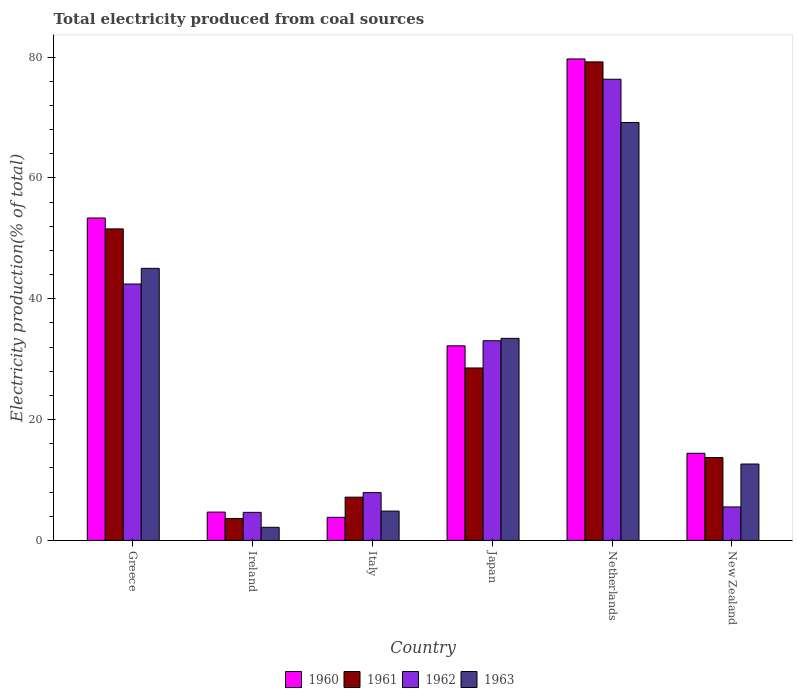How many different coloured bars are there?
Your answer should be very brief. 4. How many groups of bars are there?
Your response must be concise. 6. Are the number of bars on each tick of the X-axis equal?
Give a very brief answer. Yes. What is the label of the 1st group of bars from the left?
Your response must be concise. Greece. In how many cases, is the number of bars for a given country not equal to the number of legend labels?
Offer a terse response. 0. What is the total electricity produced in 1962 in Netherlands?
Offer a terse response. 76.33. Across all countries, what is the maximum total electricity produced in 1961?
Make the answer very short. 79.2. Across all countries, what is the minimum total electricity produced in 1962?
Provide a succinct answer. 4.64. In which country was the total electricity produced in 1962 minimum?
Provide a succinct answer. Ireland. What is the total total electricity produced in 1960 in the graph?
Ensure brevity in your answer.  188.18. What is the difference between the total electricity produced in 1963 in Ireland and that in Netherlands?
Make the answer very short. -67.01. What is the difference between the total electricity produced in 1962 in Greece and the total electricity produced in 1961 in Japan?
Ensure brevity in your answer.  13.9. What is the average total electricity produced in 1960 per country?
Your answer should be compact. 31.36. What is the difference between the total electricity produced of/in 1960 and total electricity produced of/in 1961 in Ireland?
Offer a terse response. 1.06. In how many countries, is the total electricity produced in 1962 greater than 20 %?
Give a very brief answer. 3. What is the ratio of the total electricity produced in 1960 in Netherlands to that in New Zealand?
Offer a terse response. 5.53. Is the total electricity produced in 1962 in Ireland less than that in New Zealand?
Ensure brevity in your answer.  Yes. What is the difference between the highest and the second highest total electricity produced in 1960?
Ensure brevity in your answer.  -21.15. What is the difference between the highest and the lowest total electricity produced in 1960?
Offer a very short reply. 75.87. Is the sum of the total electricity produced in 1961 in Greece and Ireland greater than the maximum total electricity produced in 1962 across all countries?
Keep it short and to the point. No. Is it the case that in every country, the sum of the total electricity produced in 1960 and total electricity produced in 1962 is greater than the total electricity produced in 1961?
Provide a succinct answer. Yes. How many bars are there?
Offer a terse response. 24. What is the difference between two consecutive major ticks on the Y-axis?
Offer a very short reply. 20. Are the values on the major ticks of Y-axis written in scientific E-notation?
Ensure brevity in your answer.  No. Does the graph contain any zero values?
Your answer should be compact. No. Does the graph contain grids?
Provide a succinct answer. No. Where does the legend appear in the graph?
Offer a terse response. Bottom center. What is the title of the graph?
Keep it short and to the point. Total electricity produced from coal sources. Does "1963" appear as one of the legend labels in the graph?
Make the answer very short. Yes. What is the label or title of the X-axis?
Provide a succinct answer. Country. What is the label or title of the Y-axis?
Your answer should be compact. Electricity production(% of total). What is the Electricity production(% of total) of 1960 in Greece?
Offer a very short reply. 53.36. What is the Electricity production(% of total) of 1961 in Greece?
Keep it short and to the point. 51.56. What is the Electricity production(% of total) in 1962 in Greece?
Give a very brief answer. 42.44. What is the Electricity production(% of total) of 1963 in Greece?
Your response must be concise. 45.03. What is the Electricity production(% of total) of 1960 in Ireland?
Make the answer very short. 4.69. What is the Electricity production(% of total) in 1961 in Ireland?
Offer a very short reply. 3.63. What is the Electricity production(% of total) of 1962 in Ireland?
Your answer should be very brief. 4.64. What is the Electricity production(% of total) in 1963 in Ireland?
Your answer should be compact. 2.16. What is the Electricity production(% of total) of 1960 in Italy?
Your answer should be very brief. 3.82. What is the Electricity production(% of total) in 1961 in Italy?
Provide a succinct answer. 7.15. What is the Electricity production(% of total) of 1962 in Italy?
Provide a short and direct response. 7.91. What is the Electricity production(% of total) of 1963 in Italy?
Your answer should be very brief. 4.85. What is the Electricity production(% of total) of 1960 in Japan?
Provide a succinct answer. 32.21. What is the Electricity production(% of total) in 1961 in Japan?
Keep it short and to the point. 28.54. What is the Electricity production(% of total) of 1962 in Japan?
Your answer should be very brief. 33.05. What is the Electricity production(% of total) of 1963 in Japan?
Ensure brevity in your answer.  33.44. What is the Electricity production(% of total) in 1960 in Netherlands?
Offer a very short reply. 79.69. What is the Electricity production(% of total) of 1961 in Netherlands?
Your response must be concise. 79.2. What is the Electricity production(% of total) in 1962 in Netherlands?
Make the answer very short. 76.33. What is the Electricity production(% of total) of 1963 in Netherlands?
Your response must be concise. 69.17. What is the Electricity production(% of total) of 1960 in New Zealand?
Offer a terse response. 14.42. What is the Electricity production(% of total) of 1961 in New Zealand?
Make the answer very short. 13.71. What is the Electricity production(% of total) in 1962 in New Zealand?
Provide a succinct answer. 5.54. What is the Electricity production(% of total) in 1963 in New Zealand?
Give a very brief answer. 12.64. Across all countries, what is the maximum Electricity production(% of total) of 1960?
Offer a terse response. 79.69. Across all countries, what is the maximum Electricity production(% of total) in 1961?
Make the answer very short. 79.2. Across all countries, what is the maximum Electricity production(% of total) of 1962?
Your answer should be compact. 76.33. Across all countries, what is the maximum Electricity production(% of total) of 1963?
Your answer should be very brief. 69.17. Across all countries, what is the minimum Electricity production(% of total) of 1960?
Offer a terse response. 3.82. Across all countries, what is the minimum Electricity production(% of total) of 1961?
Keep it short and to the point. 3.63. Across all countries, what is the minimum Electricity production(% of total) in 1962?
Offer a very short reply. 4.64. Across all countries, what is the minimum Electricity production(% of total) in 1963?
Offer a very short reply. 2.16. What is the total Electricity production(% of total) of 1960 in the graph?
Offer a terse response. 188.18. What is the total Electricity production(% of total) in 1961 in the graph?
Give a very brief answer. 183.8. What is the total Electricity production(% of total) in 1962 in the graph?
Ensure brevity in your answer.  169.91. What is the total Electricity production(% of total) of 1963 in the graph?
Provide a short and direct response. 167.3. What is the difference between the Electricity production(% of total) of 1960 in Greece and that in Ireland?
Make the answer very short. 48.68. What is the difference between the Electricity production(% of total) in 1961 in Greece and that in Ireland?
Offer a terse response. 47.93. What is the difference between the Electricity production(% of total) of 1962 in Greece and that in Ireland?
Provide a succinct answer. 37.8. What is the difference between the Electricity production(% of total) in 1963 in Greece and that in Ireland?
Give a very brief answer. 42.87. What is the difference between the Electricity production(% of total) of 1960 in Greece and that in Italy?
Make the answer very short. 49.54. What is the difference between the Electricity production(% of total) of 1961 in Greece and that in Italy?
Your answer should be compact. 44.41. What is the difference between the Electricity production(% of total) in 1962 in Greece and that in Italy?
Keep it short and to the point. 34.53. What is the difference between the Electricity production(% of total) in 1963 in Greece and that in Italy?
Give a very brief answer. 40.18. What is the difference between the Electricity production(% of total) in 1960 in Greece and that in Japan?
Keep it short and to the point. 21.15. What is the difference between the Electricity production(% of total) of 1961 in Greece and that in Japan?
Offer a terse response. 23.02. What is the difference between the Electricity production(% of total) of 1962 in Greece and that in Japan?
Give a very brief answer. 9.39. What is the difference between the Electricity production(% of total) in 1963 in Greece and that in Japan?
Make the answer very short. 11.59. What is the difference between the Electricity production(% of total) of 1960 in Greece and that in Netherlands?
Provide a succinct answer. -26.33. What is the difference between the Electricity production(% of total) in 1961 in Greece and that in Netherlands?
Your answer should be compact. -27.64. What is the difference between the Electricity production(% of total) of 1962 in Greece and that in Netherlands?
Your answer should be compact. -33.89. What is the difference between the Electricity production(% of total) of 1963 in Greece and that in Netherlands?
Your answer should be compact. -24.14. What is the difference between the Electricity production(% of total) of 1960 in Greece and that in New Zealand?
Ensure brevity in your answer.  38.95. What is the difference between the Electricity production(% of total) in 1961 in Greece and that in New Zealand?
Ensure brevity in your answer.  37.85. What is the difference between the Electricity production(% of total) of 1962 in Greece and that in New Zealand?
Offer a very short reply. 36.9. What is the difference between the Electricity production(% of total) of 1963 in Greece and that in New Zealand?
Provide a succinct answer. 32.39. What is the difference between the Electricity production(% of total) in 1960 in Ireland and that in Italy?
Keep it short and to the point. 0.87. What is the difference between the Electricity production(% of total) of 1961 in Ireland and that in Italy?
Offer a terse response. -3.53. What is the difference between the Electricity production(% of total) in 1962 in Ireland and that in Italy?
Your answer should be very brief. -3.27. What is the difference between the Electricity production(% of total) in 1963 in Ireland and that in Italy?
Offer a very short reply. -2.69. What is the difference between the Electricity production(% of total) in 1960 in Ireland and that in Japan?
Your response must be concise. -27.52. What is the difference between the Electricity production(% of total) of 1961 in Ireland and that in Japan?
Provide a succinct answer. -24.91. What is the difference between the Electricity production(% of total) of 1962 in Ireland and that in Japan?
Make the answer very short. -28.41. What is the difference between the Electricity production(% of total) of 1963 in Ireland and that in Japan?
Offer a terse response. -31.28. What is the difference between the Electricity production(% of total) in 1960 in Ireland and that in Netherlands?
Provide a succinct answer. -75.01. What is the difference between the Electricity production(% of total) of 1961 in Ireland and that in Netherlands?
Provide a short and direct response. -75.58. What is the difference between the Electricity production(% of total) in 1962 in Ireland and that in Netherlands?
Make the answer very short. -71.69. What is the difference between the Electricity production(% of total) in 1963 in Ireland and that in Netherlands?
Make the answer very short. -67.01. What is the difference between the Electricity production(% of total) of 1960 in Ireland and that in New Zealand?
Your response must be concise. -9.73. What is the difference between the Electricity production(% of total) in 1961 in Ireland and that in New Zealand?
Your answer should be compact. -10.08. What is the difference between the Electricity production(% of total) in 1962 in Ireland and that in New Zealand?
Keep it short and to the point. -0.9. What is the difference between the Electricity production(% of total) of 1963 in Ireland and that in New Zealand?
Your answer should be very brief. -10.48. What is the difference between the Electricity production(% of total) of 1960 in Italy and that in Japan?
Your answer should be compact. -28.39. What is the difference between the Electricity production(% of total) in 1961 in Italy and that in Japan?
Provide a short and direct response. -21.38. What is the difference between the Electricity production(% of total) of 1962 in Italy and that in Japan?
Provide a succinct answer. -25.14. What is the difference between the Electricity production(% of total) in 1963 in Italy and that in Japan?
Offer a terse response. -28.59. What is the difference between the Electricity production(% of total) in 1960 in Italy and that in Netherlands?
Offer a terse response. -75.87. What is the difference between the Electricity production(% of total) in 1961 in Italy and that in Netherlands?
Give a very brief answer. -72.05. What is the difference between the Electricity production(% of total) of 1962 in Italy and that in Netherlands?
Provide a succinct answer. -68.42. What is the difference between the Electricity production(% of total) of 1963 in Italy and that in Netherlands?
Keep it short and to the point. -64.32. What is the difference between the Electricity production(% of total) in 1960 in Italy and that in New Zealand?
Ensure brevity in your answer.  -10.6. What is the difference between the Electricity production(% of total) in 1961 in Italy and that in New Zealand?
Give a very brief answer. -6.55. What is the difference between the Electricity production(% of total) in 1962 in Italy and that in New Zealand?
Provide a short and direct response. 2.37. What is the difference between the Electricity production(% of total) of 1963 in Italy and that in New Zealand?
Offer a very short reply. -7.79. What is the difference between the Electricity production(% of total) of 1960 in Japan and that in Netherlands?
Provide a short and direct response. -47.48. What is the difference between the Electricity production(% of total) in 1961 in Japan and that in Netherlands?
Your response must be concise. -50.67. What is the difference between the Electricity production(% of total) in 1962 in Japan and that in Netherlands?
Provide a short and direct response. -43.28. What is the difference between the Electricity production(% of total) in 1963 in Japan and that in Netherlands?
Provide a short and direct response. -35.73. What is the difference between the Electricity production(% of total) in 1960 in Japan and that in New Zealand?
Offer a very short reply. 17.79. What is the difference between the Electricity production(% of total) of 1961 in Japan and that in New Zealand?
Provide a succinct answer. 14.83. What is the difference between the Electricity production(% of total) in 1962 in Japan and that in New Zealand?
Provide a short and direct response. 27.51. What is the difference between the Electricity production(% of total) of 1963 in Japan and that in New Zealand?
Make the answer very short. 20.8. What is the difference between the Electricity production(% of total) in 1960 in Netherlands and that in New Zealand?
Provide a succinct answer. 65.28. What is the difference between the Electricity production(% of total) in 1961 in Netherlands and that in New Zealand?
Offer a terse response. 65.5. What is the difference between the Electricity production(% of total) in 1962 in Netherlands and that in New Zealand?
Ensure brevity in your answer.  70.8. What is the difference between the Electricity production(% of total) of 1963 in Netherlands and that in New Zealand?
Offer a very short reply. 56.53. What is the difference between the Electricity production(% of total) of 1960 in Greece and the Electricity production(% of total) of 1961 in Ireland?
Offer a very short reply. 49.73. What is the difference between the Electricity production(% of total) of 1960 in Greece and the Electricity production(% of total) of 1962 in Ireland?
Ensure brevity in your answer.  48.72. What is the difference between the Electricity production(% of total) of 1960 in Greece and the Electricity production(% of total) of 1963 in Ireland?
Provide a succinct answer. 51.2. What is the difference between the Electricity production(% of total) in 1961 in Greece and the Electricity production(% of total) in 1962 in Ireland?
Your answer should be compact. 46.92. What is the difference between the Electricity production(% of total) of 1961 in Greece and the Electricity production(% of total) of 1963 in Ireland?
Ensure brevity in your answer.  49.4. What is the difference between the Electricity production(% of total) in 1962 in Greece and the Electricity production(% of total) in 1963 in Ireland?
Offer a terse response. 40.27. What is the difference between the Electricity production(% of total) in 1960 in Greece and the Electricity production(% of total) in 1961 in Italy?
Provide a succinct answer. 46.21. What is the difference between the Electricity production(% of total) in 1960 in Greece and the Electricity production(% of total) in 1962 in Italy?
Your answer should be very brief. 45.45. What is the difference between the Electricity production(% of total) of 1960 in Greece and the Electricity production(% of total) of 1963 in Italy?
Provide a short and direct response. 48.51. What is the difference between the Electricity production(% of total) of 1961 in Greece and the Electricity production(% of total) of 1962 in Italy?
Keep it short and to the point. 43.65. What is the difference between the Electricity production(% of total) in 1961 in Greece and the Electricity production(% of total) in 1963 in Italy?
Make the answer very short. 46.71. What is the difference between the Electricity production(% of total) of 1962 in Greece and the Electricity production(% of total) of 1963 in Italy?
Offer a very short reply. 37.59. What is the difference between the Electricity production(% of total) in 1960 in Greece and the Electricity production(% of total) in 1961 in Japan?
Provide a succinct answer. 24.82. What is the difference between the Electricity production(% of total) of 1960 in Greece and the Electricity production(% of total) of 1962 in Japan?
Give a very brief answer. 20.31. What is the difference between the Electricity production(% of total) in 1960 in Greece and the Electricity production(% of total) in 1963 in Japan?
Your answer should be very brief. 19.92. What is the difference between the Electricity production(% of total) in 1961 in Greece and the Electricity production(% of total) in 1962 in Japan?
Your answer should be compact. 18.51. What is the difference between the Electricity production(% of total) of 1961 in Greece and the Electricity production(% of total) of 1963 in Japan?
Give a very brief answer. 18.12. What is the difference between the Electricity production(% of total) of 1962 in Greece and the Electricity production(% of total) of 1963 in Japan?
Offer a very short reply. 9. What is the difference between the Electricity production(% of total) of 1960 in Greece and the Electricity production(% of total) of 1961 in Netherlands?
Offer a very short reply. -25.84. What is the difference between the Electricity production(% of total) in 1960 in Greece and the Electricity production(% of total) in 1962 in Netherlands?
Keep it short and to the point. -22.97. What is the difference between the Electricity production(% of total) in 1960 in Greece and the Electricity production(% of total) in 1963 in Netherlands?
Ensure brevity in your answer.  -15.81. What is the difference between the Electricity production(% of total) of 1961 in Greece and the Electricity production(% of total) of 1962 in Netherlands?
Offer a very short reply. -24.77. What is the difference between the Electricity production(% of total) of 1961 in Greece and the Electricity production(% of total) of 1963 in Netherlands?
Make the answer very short. -17.61. What is the difference between the Electricity production(% of total) of 1962 in Greece and the Electricity production(% of total) of 1963 in Netherlands?
Offer a terse response. -26.73. What is the difference between the Electricity production(% of total) of 1960 in Greece and the Electricity production(% of total) of 1961 in New Zealand?
Your answer should be very brief. 39.65. What is the difference between the Electricity production(% of total) in 1960 in Greece and the Electricity production(% of total) in 1962 in New Zealand?
Keep it short and to the point. 47.83. What is the difference between the Electricity production(% of total) of 1960 in Greece and the Electricity production(% of total) of 1963 in New Zealand?
Provide a short and direct response. 40.72. What is the difference between the Electricity production(% of total) in 1961 in Greece and the Electricity production(% of total) in 1962 in New Zealand?
Keep it short and to the point. 46.03. What is the difference between the Electricity production(% of total) in 1961 in Greece and the Electricity production(% of total) in 1963 in New Zealand?
Ensure brevity in your answer.  38.92. What is the difference between the Electricity production(% of total) of 1962 in Greece and the Electricity production(% of total) of 1963 in New Zealand?
Your response must be concise. 29.8. What is the difference between the Electricity production(% of total) of 1960 in Ireland and the Electricity production(% of total) of 1961 in Italy?
Provide a succinct answer. -2.47. What is the difference between the Electricity production(% of total) in 1960 in Ireland and the Electricity production(% of total) in 1962 in Italy?
Ensure brevity in your answer.  -3.22. What is the difference between the Electricity production(% of total) in 1960 in Ireland and the Electricity production(% of total) in 1963 in Italy?
Make the answer very short. -0.17. What is the difference between the Electricity production(% of total) in 1961 in Ireland and the Electricity production(% of total) in 1962 in Italy?
Provide a short and direct response. -4.28. What is the difference between the Electricity production(% of total) in 1961 in Ireland and the Electricity production(% of total) in 1963 in Italy?
Give a very brief answer. -1.22. What is the difference between the Electricity production(% of total) of 1962 in Ireland and the Electricity production(% of total) of 1963 in Italy?
Offer a terse response. -0.21. What is the difference between the Electricity production(% of total) of 1960 in Ireland and the Electricity production(% of total) of 1961 in Japan?
Provide a short and direct response. -23.85. What is the difference between the Electricity production(% of total) in 1960 in Ireland and the Electricity production(% of total) in 1962 in Japan?
Provide a succinct answer. -28.36. What is the difference between the Electricity production(% of total) in 1960 in Ireland and the Electricity production(% of total) in 1963 in Japan?
Offer a very short reply. -28.76. What is the difference between the Electricity production(% of total) of 1961 in Ireland and the Electricity production(% of total) of 1962 in Japan?
Your answer should be compact. -29.42. What is the difference between the Electricity production(% of total) of 1961 in Ireland and the Electricity production(% of total) of 1963 in Japan?
Provide a succinct answer. -29.82. What is the difference between the Electricity production(% of total) of 1962 in Ireland and the Electricity production(% of total) of 1963 in Japan?
Offer a very short reply. -28.8. What is the difference between the Electricity production(% of total) of 1960 in Ireland and the Electricity production(% of total) of 1961 in Netherlands?
Offer a terse response. -74.52. What is the difference between the Electricity production(% of total) of 1960 in Ireland and the Electricity production(% of total) of 1962 in Netherlands?
Offer a very short reply. -71.65. What is the difference between the Electricity production(% of total) of 1960 in Ireland and the Electricity production(% of total) of 1963 in Netherlands?
Offer a very short reply. -64.49. What is the difference between the Electricity production(% of total) in 1961 in Ireland and the Electricity production(% of total) in 1962 in Netherlands?
Make the answer very short. -72.71. What is the difference between the Electricity production(% of total) in 1961 in Ireland and the Electricity production(% of total) in 1963 in Netherlands?
Make the answer very short. -65.54. What is the difference between the Electricity production(% of total) of 1962 in Ireland and the Electricity production(% of total) of 1963 in Netherlands?
Your answer should be very brief. -64.53. What is the difference between the Electricity production(% of total) in 1960 in Ireland and the Electricity production(% of total) in 1961 in New Zealand?
Give a very brief answer. -9.02. What is the difference between the Electricity production(% of total) in 1960 in Ireland and the Electricity production(% of total) in 1962 in New Zealand?
Keep it short and to the point. -0.85. What is the difference between the Electricity production(% of total) of 1960 in Ireland and the Electricity production(% of total) of 1963 in New Zealand?
Offer a terse response. -7.95. What is the difference between the Electricity production(% of total) of 1961 in Ireland and the Electricity production(% of total) of 1962 in New Zealand?
Give a very brief answer. -1.91. What is the difference between the Electricity production(% of total) of 1961 in Ireland and the Electricity production(% of total) of 1963 in New Zealand?
Your answer should be very brief. -9.01. What is the difference between the Electricity production(% of total) in 1962 in Ireland and the Electricity production(% of total) in 1963 in New Zealand?
Ensure brevity in your answer.  -8. What is the difference between the Electricity production(% of total) in 1960 in Italy and the Electricity production(% of total) in 1961 in Japan?
Provide a short and direct response. -24.72. What is the difference between the Electricity production(% of total) in 1960 in Italy and the Electricity production(% of total) in 1962 in Japan?
Give a very brief answer. -29.23. What is the difference between the Electricity production(% of total) of 1960 in Italy and the Electricity production(% of total) of 1963 in Japan?
Offer a very short reply. -29.63. What is the difference between the Electricity production(% of total) of 1961 in Italy and the Electricity production(% of total) of 1962 in Japan?
Keep it short and to the point. -25.89. What is the difference between the Electricity production(% of total) of 1961 in Italy and the Electricity production(% of total) of 1963 in Japan?
Make the answer very short. -26.29. What is the difference between the Electricity production(% of total) of 1962 in Italy and the Electricity production(% of total) of 1963 in Japan?
Your answer should be compact. -25.53. What is the difference between the Electricity production(% of total) of 1960 in Italy and the Electricity production(% of total) of 1961 in Netherlands?
Provide a short and direct response. -75.39. What is the difference between the Electricity production(% of total) of 1960 in Italy and the Electricity production(% of total) of 1962 in Netherlands?
Your answer should be very brief. -72.51. What is the difference between the Electricity production(% of total) of 1960 in Italy and the Electricity production(% of total) of 1963 in Netherlands?
Ensure brevity in your answer.  -65.35. What is the difference between the Electricity production(% of total) of 1961 in Italy and the Electricity production(% of total) of 1962 in Netherlands?
Provide a succinct answer. -69.18. What is the difference between the Electricity production(% of total) in 1961 in Italy and the Electricity production(% of total) in 1963 in Netherlands?
Offer a very short reply. -62.02. What is the difference between the Electricity production(% of total) of 1962 in Italy and the Electricity production(% of total) of 1963 in Netherlands?
Your response must be concise. -61.26. What is the difference between the Electricity production(% of total) of 1960 in Italy and the Electricity production(% of total) of 1961 in New Zealand?
Provide a short and direct response. -9.89. What is the difference between the Electricity production(% of total) in 1960 in Italy and the Electricity production(% of total) in 1962 in New Zealand?
Your response must be concise. -1.72. What is the difference between the Electricity production(% of total) in 1960 in Italy and the Electricity production(% of total) in 1963 in New Zealand?
Your answer should be compact. -8.82. What is the difference between the Electricity production(% of total) in 1961 in Italy and the Electricity production(% of total) in 1962 in New Zealand?
Your response must be concise. 1.62. What is the difference between the Electricity production(% of total) in 1961 in Italy and the Electricity production(% of total) in 1963 in New Zealand?
Provide a succinct answer. -5.49. What is the difference between the Electricity production(% of total) of 1962 in Italy and the Electricity production(% of total) of 1963 in New Zealand?
Offer a terse response. -4.73. What is the difference between the Electricity production(% of total) in 1960 in Japan and the Electricity production(% of total) in 1961 in Netherlands?
Offer a very short reply. -47. What is the difference between the Electricity production(% of total) in 1960 in Japan and the Electricity production(% of total) in 1962 in Netherlands?
Offer a very short reply. -44.13. What is the difference between the Electricity production(% of total) in 1960 in Japan and the Electricity production(% of total) in 1963 in Netherlands?
Offer a terse response. -36.96. What is the difference between the Electricity production(% of total) in 1961 in Japan and the Electricity production(% of total) in 1962 in Netherlands?
Provide a short and direct response. -47.79. What is the difference between the Electricity production(% of total) in 1961 in Japan and the Electricity production(% of total) in 1963 in Netherlands?
Keep it short and to the point. -40.63. What is the difference between the Electricity production(% of total) of 1962 in Japan and the Electricity production(% of total) of 1963 in Netherlands?
Provide a short and direct response. -36.12. What is the difference between the Electricity production(% of total) in 1960 in Japan and the Electricity production(% of total) in 1961 in New Zealand?
Your answer should be compact. 18.5. What is the difference between the Electricity production(% of total) of 1960 in Japan and the Electricity production(% of total) of 1962 in New Zealand?
Provide a succinct answer. 26.67. What is the difference between the Electricity production(% of total) in 1960 in Japan and the Electricity production(% of total) in 1963 in New Zealand?
Offer a very short reply. 19.57. What is the difference between the Electricity production(% of total) in 1961 in Japan and the Electricity production(% of total) in 1962 in New Zealand?
Give a very brief answer. 23. What is the difference between the Electricity production(% of total) in 1961 in Japan and the Electricity production(% of total) in 1963 in New Zealand?
Your answer should be compact. 15.9. What is the difference between the Electricity production(% of total) of 1962 in Japan and the Electricity production(% of total) of 1963 in New Zealand?
Provide a short and direct response. 20.41. What is the difference between the Electricity production(% of total) of 1960 in Netherlands and the Electricity production(% of total) of 1961 in New Zealand?
Ensure brevity in your answer.  65.98. What is the difference between the Electricity production(% of total) in 1960 in Netherlands and the Electricity production(% of total) in 1962 in New Zealand?
Make the answer very short. 74.16. What is the difference between the Electricity production(% of total) of 1960 in Netherlands and the Electricity production(% of total) of 1963 in New Zealand?
Ensure brevity in your answer.  67.05. What is the difference between the Electricity production(% of total) of 1961 in Netherlands and the Electricity production(% of total) of 1962 in New Zealand?
Offer a very short reply. 73.67. What is the difference between the Electricity production(% of total) of 1961 in Netherlands and the Electricity production(% of total) of 1963 in New Zealand?
Give a very brief answer. 66.56. What is the difference between the Electricity production(% of total) in 1962 in Netherlands and the Electricity production(% of total) in 1963 in New Zealand?
Provide a short and direct response. 63.69. What is the average Electricity production(% of total) in 1960 per country?
Keep it short and to the point. 31.36. What is the average Electricity production(% of total) of 1961 per country?
Ensure brevity in your answer.  30.63. What is the average Electricity production(% of total) in 1962 per country?
Offer a terse response. 28.32. What is the average Electricity production(% of total) of 1963 per country?
Your answer should be compact. 27.88. What is the difference between the Electricity production(% of total) of 1960 and Electricity production(% of total) of 1961 in Greece?
Provide a succinct answer. 1.8. What is the difference between the Electricity production(% of total) of 1960 and Electricity production(% of total) of 1962 in Greece?
Give a very brief answer. 10.92. What is the difference between the Electricity production(% of total) in 1960 and Electricity production(% of total) in 1963 in Greece?
Keep it short and to the point. 8.33. What is the difference between the Electricity production(% of total) in 1961 and Electricity production(% of total) in 1962 in Greece?
Offer a very short reply. 9.12. What is the difference between the Electricity production(% of total) in 1961 and Electricity production(% of total) in 1963 in Greece?
Offer a terse response. 6.53. What is the difference between the Electricity production(% of total) in 1962 and Electricity production(% of total) in 1963 in Greece?
Offer a very short reply. -2.59. What is the difference between the Electricity production(% of total) of 1960 and Electricity production(% of total) of 1961 in Ireland?
Your response must be concise. 1.06. What is the difference between the Electricity production(% of total) of 1960 and Electricity production(% of total) of 1962 in Ireland?
Ensure brevity in your answer.  0.05. What is the difference between the Electricity production(% of total) of 1960 and Electricity production(% of total) of 1963 in Ireland?
Ensure brevity in your answer.  2.52. What is the difference between the Electricity production(% of total) in 1961 and Electricity production(% of total) in 1962 in Ireland?
Your answer should be very brief. -1.01. What is the difference between the Electricity production(% of total) in 1961 and Electricity production(% of total) in 1963 in Ireland?
Your answer should be compact. 1.46. What is the difference between the Electricity production(% of total) in 1962 and Electricity production(% of total) in 1963 in Ireland?
Give a very brief answer. 2.48. What is the difference between the Electricity production(% of total) of 1960 and Electricity production(% of total) of 1961 in Italy?
Your response must be concise. -3.34. What is the difference between the Electricity production(% of total) in 1960 and Electricity production(% of total) in 1962 in Italy?
Your answer should be very brief. -4.09. What is the difference between the Electricity production(% of total) in 1960 and Electricity production(% of total) in 1963 in Italy?
Your answer should be very brief. -1.03. What is the difference between the Electricity production(% of total) of 1961 and Electricity production(% of total) of 1962 in Italy?
Provide a succinct answer. -0.75. What is the difference between the Electricity production(% of total) of 1961 and Electricity production(% of total) of 1963 in Italy?
Ensure brevity in your answer.  2.3. What is the difference between the Electricity production(% of total) in 1962 and Electricity production(% of total) in 1963 in Italy?
Make the answer very short. 3.06. What is the difference between the Electricity production(% of total) of 1960 and Electricity production(% of total) of 1961 in Japan?
Make the answer very short. 3.67. What is the difference between the Electricity production(% of total) of 1960 and Electricity production(% of total) of 1962 in Japan?
Give a very brief answer. -0.84. What is the difference between the Electricity production(% of total) of 1960 and Electricity production(% of total) of 1963 in Japan?
Offer a very short reply. -1.24. What is the difference between the Electricity production(% of total) of 1961 and Electricity production(% of total) of 1962 in Japan?
Your response must be concise. -4.51. What is the difference between the Electricity production(% of total) in 1961 and Electricity production(% of total) in 1963 in Japan?
Offer a terse response. -4.9. What is the difference between the Electricity production(% of total) in 1962 and Electricity production(% of total) in 1963 in Japan?
Your answer should be very brief. -0.4. What is the difference between the Electricity production(% of total) in 1960 and Electricity production(% of total) in 1961 in Netherlands?
Provide a succinct answer. 0.49. What is the difference between the Electricity production(% of total) in 1960 and Electricity production(% of total) in 1962 in Netherlands?
Provide a short and direct response. 3.36. What is the difference between the Electricity production(% of total) in 1960 and Electricity production(% of total) in 1963 in Netherlands?
Your answer should be compact. 10.52. What is the difference between the Electricity production(% of total) of 1961 and Electricity production(% of total) of 1962 in Netherlands?
Offer a very short reply. 2.87. What is the difference between the Electricity production(% of total) in 1961 and Electricity production(% of total) in 1963 in Netherlands?
Keep it short and to the point. 10.03. What is the difference between the Electricity production(% of total) of 1962 and Electricity production(% of total) of 1963 in Netherlands?
Make the answer very short. 7.16. What is the difference between the Electricity production(% of total) in 1960 and Electricity production(% of total) in 1961 in New Zealand?
Give a very brief answer. 0.71. What is the difference between the Electricity production(% of total) of 1960 and Electricity production(% of total) of 1962 in New Zealand?
Provide a short and direct response. 8.88. What is the difference between the Electricity production(% of total) in 1960 and Electricity production(% of total) in 1963 in New Zealand?
Offer a very short reply. 1.78. What is the difference between the Electricity production(% of total) of 1961 and Electricity production(% of total) of 1962 in New Zealand?
Your answer should be compact. 8.17. What is the difference between the Electricity production(% of total) of 1961 and Electricity production(% of total) of 1963 in New Zealand?
Offer a terse response. 1.07. What is the difference between the Electricity production(% of total) in 1962 and Electricity production(% of total) in 1963 in New Zealand?
Provide a short and direct response. -7.1. What is the ratio of the Electricity production(% of total) in 1960 in Greece to that in Ireland?
Provide a succinct answer. 11.39. What is the ratio of the Electricity production(% of total) of 1961 in Greece to that in Ireland?
Your answer should be very brief. 14.21. What is the ratio of the Electricity production(% of total) in 1962 in Greece to that in Ireland?
Your response must be concise. 9.14. What is the ratio of the Electricity production(% of total) of 1963 in Greece to that in Ireland?
Provide a succinct answer. 20.8. What is the ratio of the Electricity production(% of total) of 1960 in Greece to that in Italy?
Your response must be concise. 13.97. What is the ratio of the Electricity production(% of total) in 1961 in Greece to that in Italy?
Your response must be concise. 7.21. What is the ratio of the Electricity production(% of total) of 1962 in Greece to that in Italy?
Offer a terse response. 5.37. What is the ratio of the Electricity production(% of total) of 1963 in Greece to that in Italy?
Ensure brevity in your answer.  9.28. What is the ratio of the Electricity production(% of total) of 1960 in Greece to that in Japan?
Your response must be concise. 1.66. What is the ratio of the Electricity production(% of total) of 1961 in Greece to that in Japan?
Offer a terse response. 1.81. What is the ratio of the Electricity production(% of total) of 1962 in Greece to that in Japan?
Provide a succinct answer. 1.28. What is the ratio of the Electricity production(% of total) of 1963 in Greece to that in Japan?
Your answer should be very brief. 1.35. What is the ratio of the Electricity production(% of total) in 1960 in Greece to that in Netherlands?
Provide a short and direct response. 0.67. What is the ratio of the Electricity production(% of total) of 1961 in Greece to that in Netherlands?
Your response must be concise. 0.65. What is the ratio of the Electricity production(% of total) in 1962 in Greece to that in Netherlands?
Provide a short and direct response. 0.56. What is the ratio of the Electricity production(% of total) in 1963 in Greece to that in Netherlands?
Your response must be concise. 0.65. What is the ratio of the Electricity production(% of total) of 1960 in Greece to that in New Zealand?
Provide a succinct answer. 3.7. What is the ratio of the Electricity production(% of total) of 1961 in Greece to that in New Zealand?
Make the answer very short. 3.76. What is the ratio of the Electricity production(% of total) of 1962 in Greece to that in New Zealand?
Ensure brevity in your answer.  7.67. What is the ratio of the Electricity production(% of total) in 1963 in Greece to that in New Zealand?
Your response must be concise. 3.56. What is the ratio of the Electricity production(% of total) in 1960 in Ireland to that in Italy?
Provide a succinct answer. 1.23. What is the ratio of the Electricity production(% of total) of 1961 in Ireland to that in Italy?
Your answer should be compact. 0.51. What is the ratio of the Electricity production(% of total) of 1962 in Ireland to that in Italy?
Offer a very short reply. 0.59. What is the ratio of the Electricity production(% of total) of 1963 in Ireland to that in Italy?
Offer a very short reply. 0.45. What is the ratio of the Electricity production(% of total) in 1960 in Ireland to that in Japan?
Provide a short and direct response. 0.15. What is the ratio of the Electricity production(% of total) of 1961 in Ireland to that in Japan?
Offer a very short reply. 0.13. What is the ratio of the Electricity production(% of total) of 1962 in Ireland to that in Japan?
Provide a succinct answer. 0.14. What is the ratio of the Electricity production(% of total) of 1963 in Ireland to that in Japan?
Your response must be concise. 0.06. What is the ratio of the Electricity production(% of total) of 1960 in Ireland to that in Netherlands?
Offer a very short reply. 0.06. What is the ratio of the Electricity production(% of total) of 1961 in Ireland to that in Netherlands?
Your response must be concise. 0.05. What is the ratio of the Electricity production(% of total) of 1962 in Ireland to that in Netherlands?
Make the answer very short. 0.06. What is the ratio of the Electricity production(% of total) in 1963 in Ireland to that in Netherlands?
Your response must be concise. 0.03. What is the ratio of the Electricity production(% of total) of 1960 in Ireland to that in New Zealand?
Your answer should be very brief. 0.33. What is the ratio of the Electricity production(% of total) in 1961 in Ireland to that in New Zealand?
Ensure brevity in your answer.  0.26. What is the ratio of the Electricity production(% of total) in 1962 in Ireland to that in New Zealand?
Your answer should be very brief. 0.84. What is the ratio of the Electricity production(% of total) in 1963 in Ireland to that in New Zealand?
Offer a very short reply. 0.17. What is the ratio of the Electricity production(% of total) in 1960 in Italy to that in Japan?
Offer a terse response. 0.12. What is the ratio of the Electricity production(% of total) in 1961 in Italy to that in Japan?
Give a very brief answer. 0.25. What is the ratio of the Electricity production(% of total) in 1962 in Italy to that in Japan?
Provide a short and direct response. 0.24. What is the ratio of the Electricity production(% of total) in 1963 in Italy to that in Japan?
Ensure brevity in your answer.  0.15. What is the ratio of the Electricity production(% of total) in 1960 in Italy to that in Netherlands?
Make the answer very short. 0.05. What is the ratio of the Electricity production(% of total) in 1961 in Italy to that in Netherlands?
Offer a terse response. 0.09. What is the ratio of the Electricity production(% of total) of 1962 in Italy to that in Netherlands?
Provide a short and direct response. 0.1. What is the ratio of the Electricity production(% of total) in 1963 in Italy to that in Netherlands?
Offer a very short reply. 0.07. What is the ratio of the Electricity production(% of total) in 1960 in Italy to that in New Zealand?
Your response must be concise. 0.26. What is the ratio of the Electricity production(% of total) of 1961 in Italy to that in New Zealand?
Your answer should be compact. 0.52. What is the ratio of the Electricity production(% of total) of 1962 in Italy to that in New Zealand?
Make the answer very short. 1.43. What is the ratio of the Electricity production(% of total) of 1963 in Italy to that in New Zealand?
Offer a terse response. 0.38. What is the ratio of the Electricity production(% of total) in 1960 in Japan to that in Netherlands?
Offer a terse response. 0.4. What is the ratio of the Electricity production(% of total) of 1961 in Japan to that in Netherlands?
Offer a terse response. 0.36. What is the ratio of the Electricity production(% of total) of 1962 in Japan to that in Netherlands?
Give a very brief answer. 0.43. What is the ratio of the Electricity production(% of total) in 1963 in Japan to that in Netherlands?
Your answer should be very brief. 0.48. What is the ratio of the Electricity production(% of total) of 1960 in Japan to that in New Zealand?
Give a very brief answer. 2.23. What is the ratio of the Electricity production(% of total) in 1961 in Japan to that in New Zealand?
Give a very brief answer. 2.08. What is the ratio of the Electricity production(% of total) in 1962 in Japan to that in New Zealand?
Your answer should be compact. 5.97. What is the ratio of the Electricity production(% of total) of 1963 in Japan to that in New Zealand?
Offer a terse response. 2.65. What is the ratio of the Electricity production(% of total) of 1960 in Netherlands to that in New Zealand?
Your answer should be very brief. 5.53. What is the ratio of the Electricity production(% of total) of 1961 in Netherlands to that in New Zealand?
Your answer should be compact. 5.78. What is the ratio of the Electricity production(% of total) of 1962 in Netherlands to that in New Zealand?
Your answer should be compact. 13.79. What is the ratio of the Electricity production(% of total) of 1963 in Netherlands to that in New Zealand?
Your response must be concise. 5.47. What is the difference between the highest and the second highest Electricity production(% of total) in 1960?
Your response must be concise. 26.33. What is the difference between the highest and the second highest Electricity production(% of total) of 1961?
Provide a short and direct response. 27.64. What is the difference between the highest and the second highest Electricity production(% of total) in 1962?
Ensure brevity in your answer.  33.89. What is the difference between the highest and the second highest Electricity production(% of total) in 1963?
Give a very brief answer. 24.14. What is the difference between the highest and the lowest Electricity production(% of total) of 1960?
Your answer should be very brief. 75.87. What is the difference between the highest and the lowest Electricity production(% of total) of 1961?
Your answer should be compact. 75.58. What is the difference between the highest and the lowest Electricity production(% of total) in 1962?
Ensure brevity in your answer.  71.69. What is the difference between the highest and the lowest Electricity production(% of total) in 1963?
Your answer should be very brief. 67.01. 